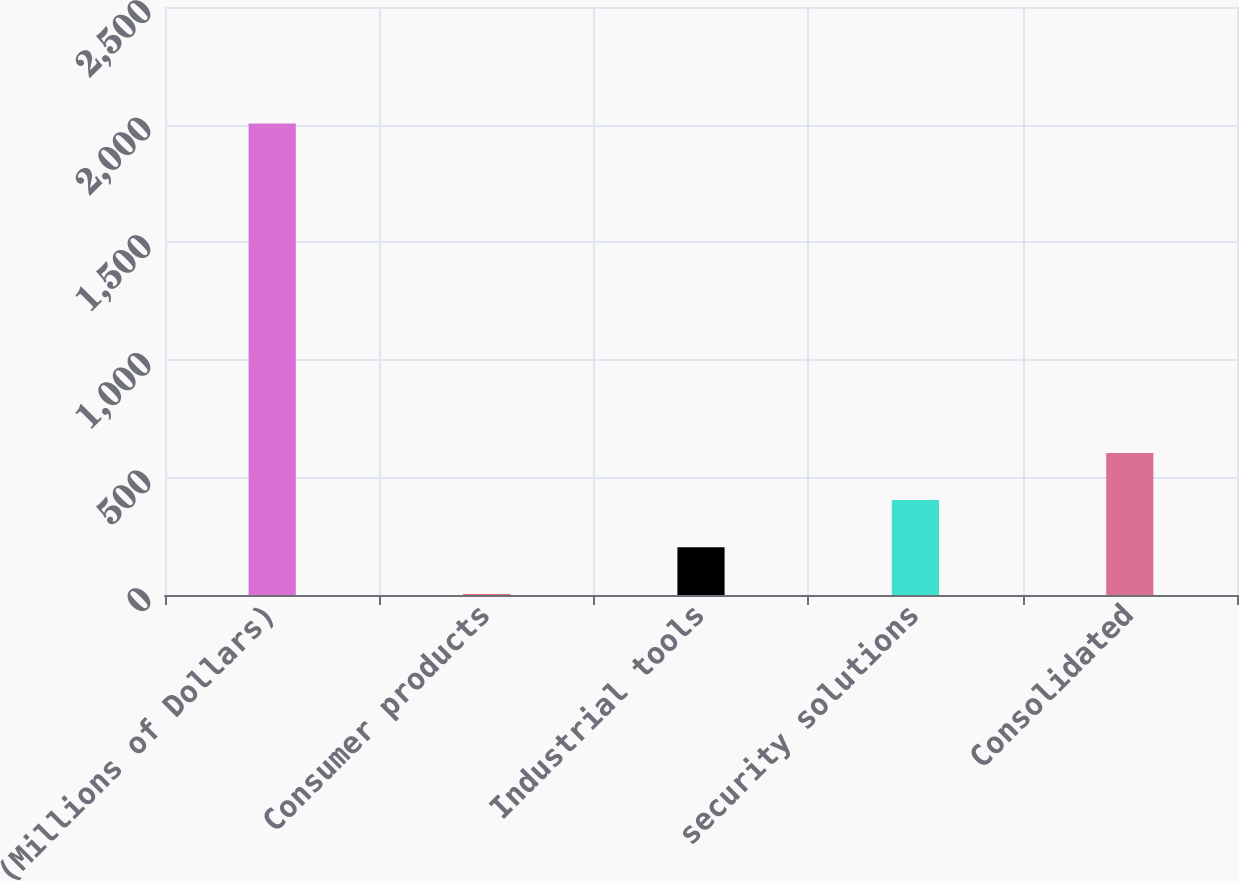Convert chart. <chart><loc_0><loc_0><loc_500><loc_500><bar_chart><fcel>(Millions of Dollars)<fcel>Consumer products<fcel>Industrial tools<fcel>security solutions<fcel>Consolidated<nl><fcel>2005<fcel>3<fcel>203.2<fcel>403.4<fcel>603.6<nl></chart> 